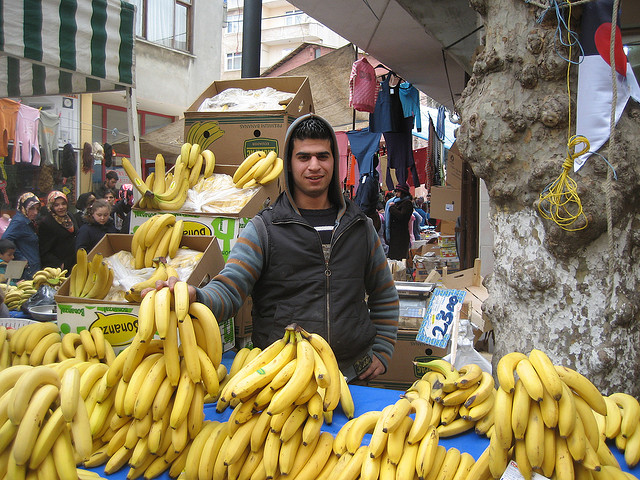How many umbrellas are red? There are no umbrellas visible in the image; the photograph showcases a person at a market stall with an abundance of bananas. 